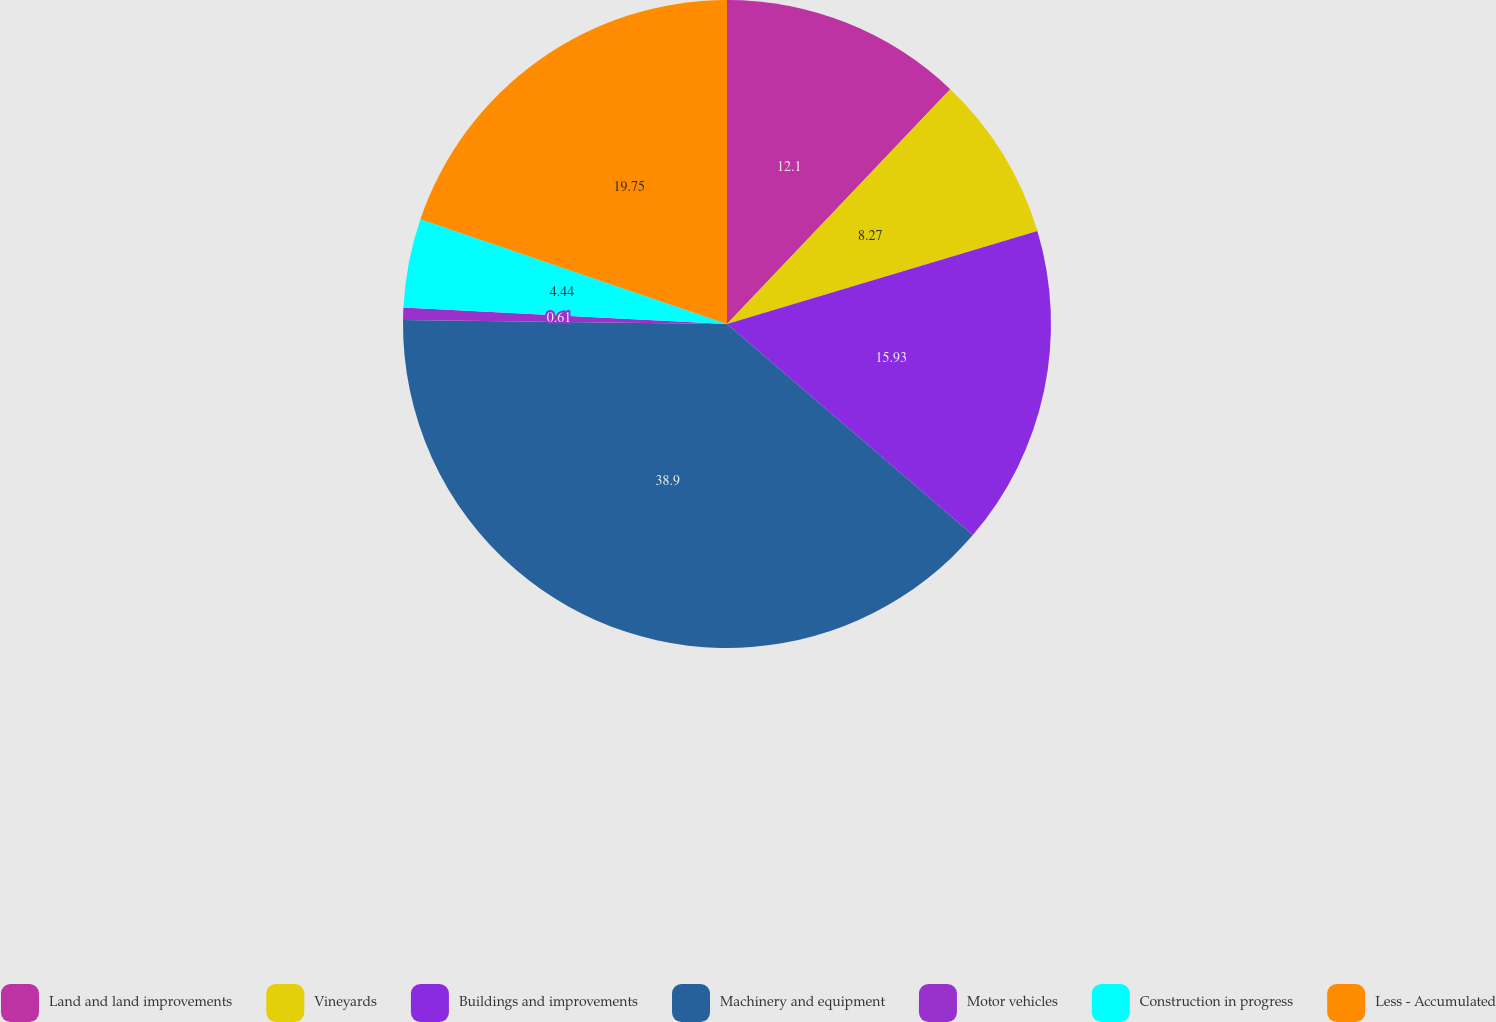Convert chart to OTSL. <chart><loc_0><loc_0><loc_500><loc_500><pie_chart><fcel>Land and land improvements<fcel>Vineyards<fcel>Buildings and improvements<fcel>Machinery and equipment<fcel>Motor vehicles<fcel>Construction in progress<fcel>Less - Accumulated<nl><fcel>12.1%<fcel>8.27%<fcel>15.93%<fcel>38.91%<fcel>0.61%<fcel>4.44%<fcel>19.76%<nl></chart> 